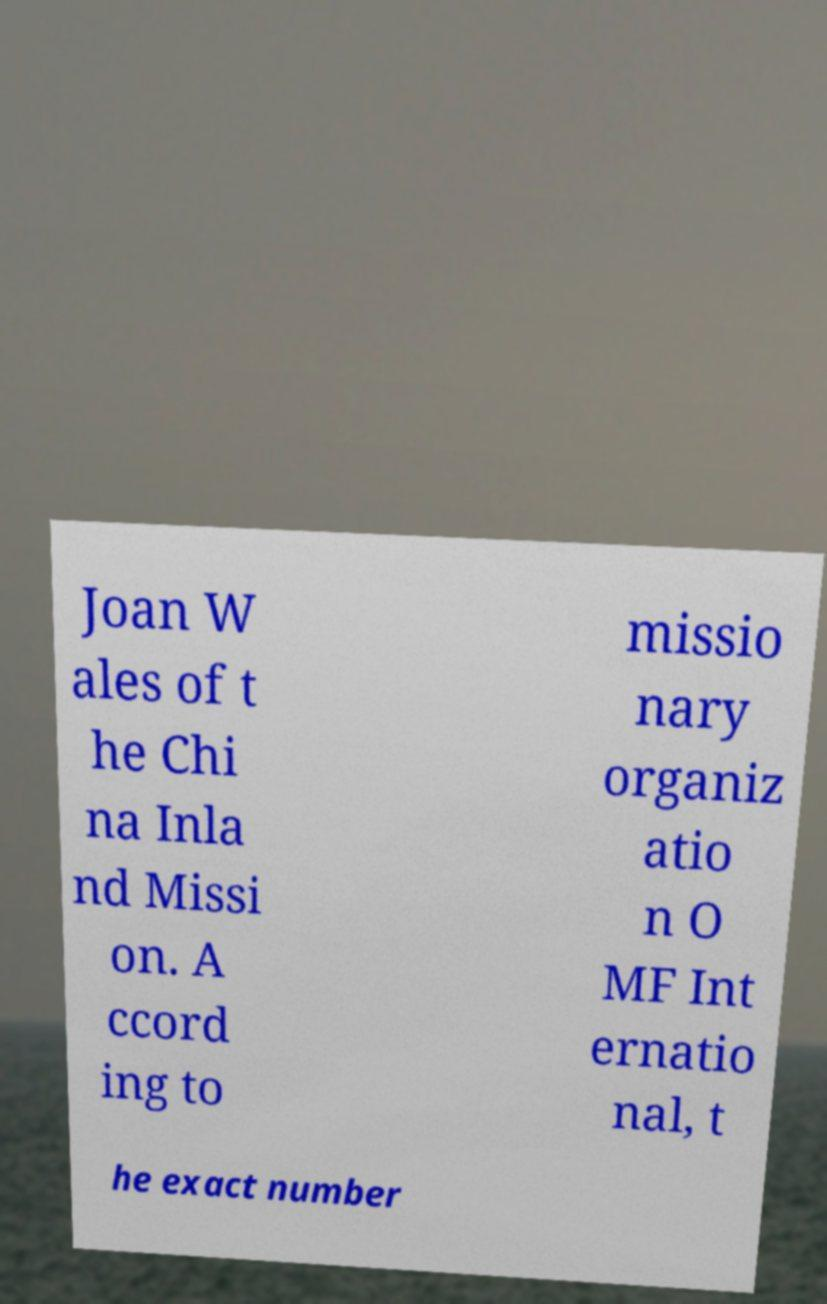Could you extract and type out the text from this image? Joan W ales of t he Chi na Inla nd Missi on. A ccord ing to missio nary organiz atio n O MF Int ernatio nal, t he exact number 